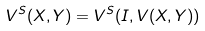<formula> <loc_0><loc_0><loc_500><loc_500>V ^ { S } ( X , Y ) = V ^ { S } ( I , V ( X , Y ) )</formula> 